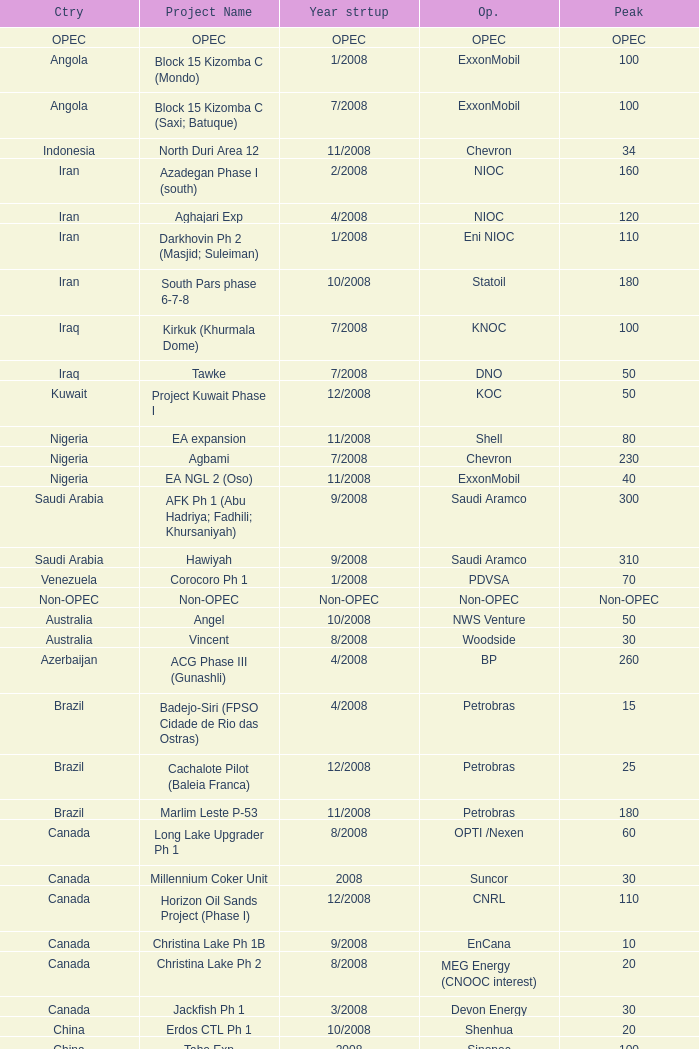What is the Project Name with a Country that is opec? OPEC. 